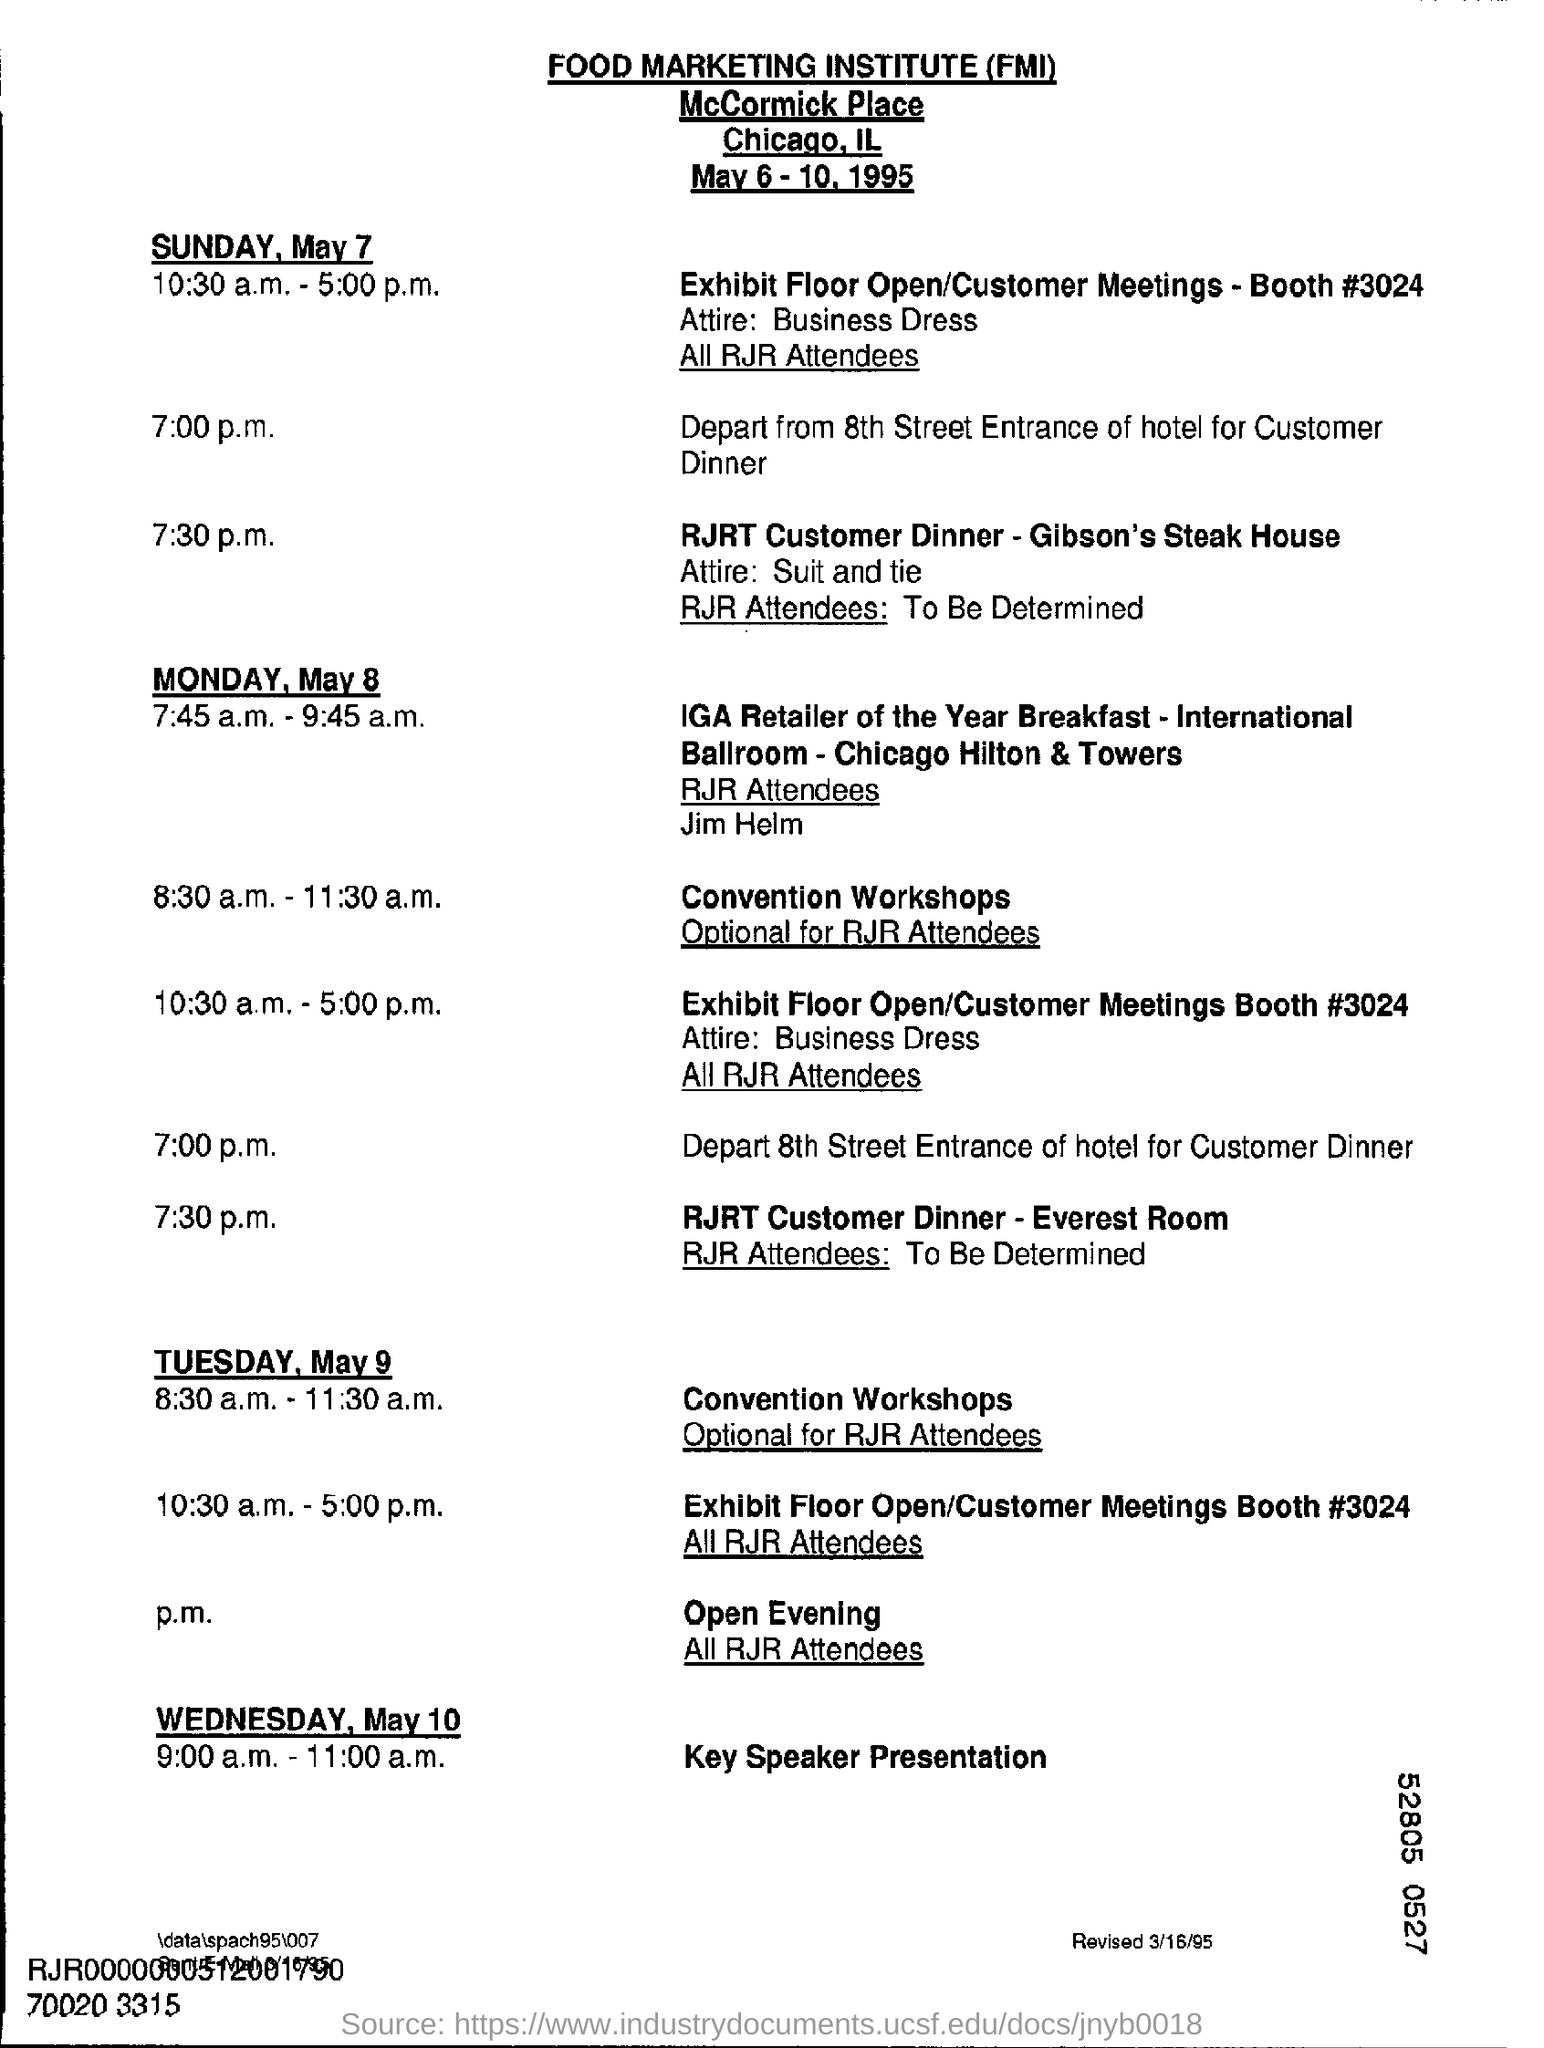What date is the meeting scheduled?
Keep it short and to the point. May 6 - 10, 1995. What is the fullform of FMI?
Provide a short and direct response. FOOD MARKETING INSTITUTE. Where is the RJRT Customer Dinner for Sunday, May 7?
Your response must be concise. Gibson's steak house. What is the Attire for the dinner?
Offer a terse response. Suit and tie. Where is the IGA Retailer of the year Breakfast held on Monday, May 8??
Provide a short and direct response. International ballroom - chicago hilton & towers. What time is the IGA Retailer of the year Breakfast held on Monday, May 8??
Ensure brevity in your answer.  7:45 a.m. - 9:45 a.m. Who are the RJR Attendees for the IGA Retailer of the year Breakfast held on Monday, May 8??
Provide a succinct answer. Jim helm. Where is the RJRT Customer Dinner held on Monday, May 8??
Ensure brevity in your answer.  Everest room. 